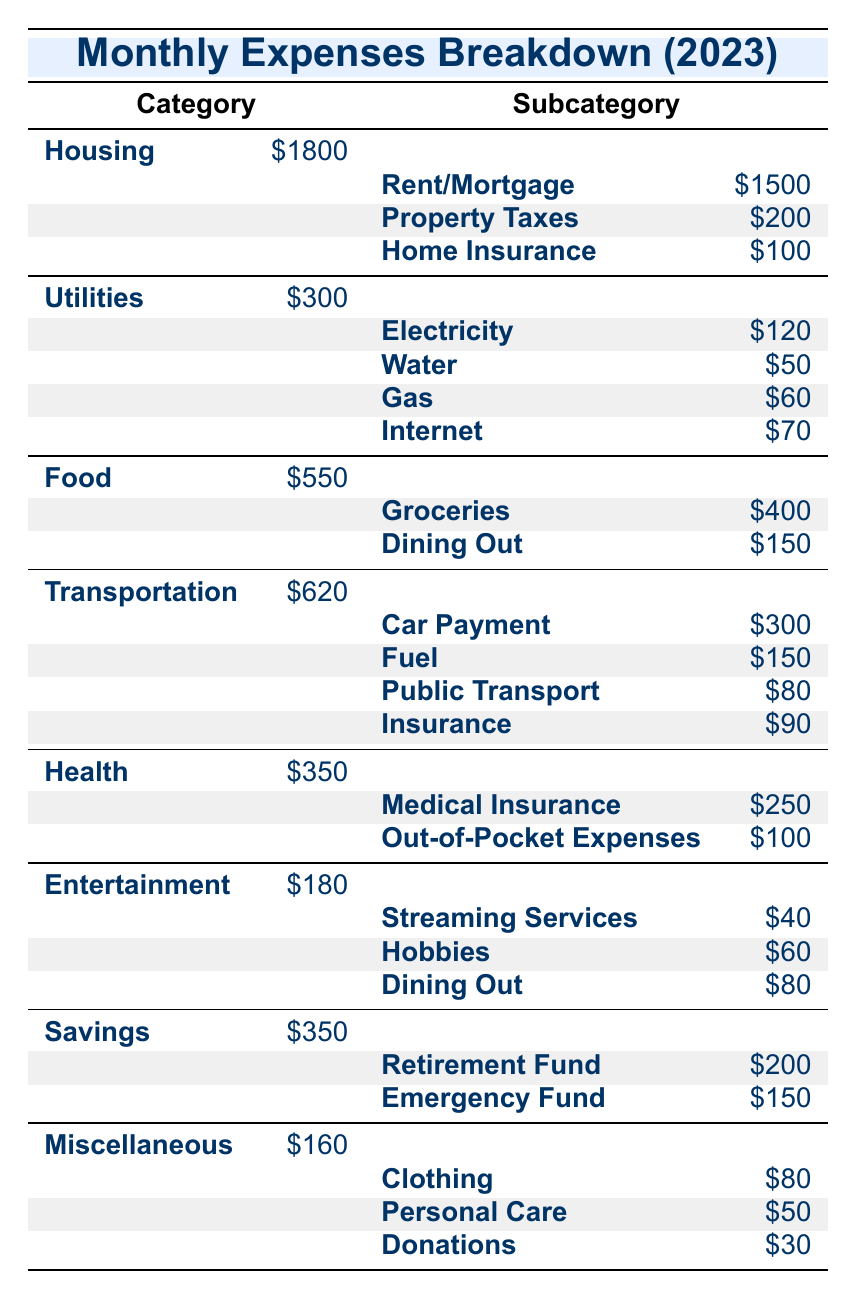What is the total spending on Housing? To find the total spending on Housing, we need to add all the subcategories under Housing: Rent/Mortgage ($1500) + Property Taxes ($200) + Home Insurance ($100) = $1800.
Answer: $1800 How much is spent on Food each month? Directly from the table, the total spending on Food is listed as $550, which combines Groceries ($400) and Dining Out ($150).
Answer: $550 Is the expenditure on Transportation greater than on Health? Comparing the Transportation total ($620) and Health total ($350) shows that $620 is greater than $350, making the statement true.
Answer: Yes What is the combined total of the Savings subcategories? The Savings subcategories are Retirement Fund ($200) and Emergency Fund ($150). Adding these together gives $200 + $150 = $350.
Answer: $350 What is the average monthly expense for Utilities? The total spending on Utilities is $300, divided among four subcategories: Electricity ($120), Water ($50), Gas ($60), and Internet ($70). The average is calculated as ($120 + $50 + $60 + $70) / 4 = $300 / 4 = $75.
Answer: $75 How much more is spent on Transportation compared to Entertainment? Transportation total is $620 and Entertainment total is $180. The difference is $620 - $180 = $440, showing that Transportation is $440 more than Entertainment.
Answer: $440 Does the household spend more on Medical Insurance than on Dining Out in the Food category? Medical Insurance costs $250, and Dining Out in the Food category costs $150. Since $250 is greater than $150, the statement is true.
Answer: Yes What is the total monthly expense for Miscellaneous? By adding all the subcategories under Miscellaneous: Clothing ($80) + Personal Care ($50) + Donations ($30) = $160.
Answer: $160 What percentage of the total monthly expenses is allocated to Entertainment? The total monthly expenses are calculated as the sum of all categories: $1800 (Housing) + $300 (Utilities) + $550 (Food) + $620 (Transportation) + $350 (Health) + $180 (Entertainment) + $350 (Savings) + $160 (Miscellaneous) = $4,010. The Entertainment expense is $180, so the percentage is ($180 / $4010) * 100 ≈ 4.48%.
Answer: Approximately 4.48% 